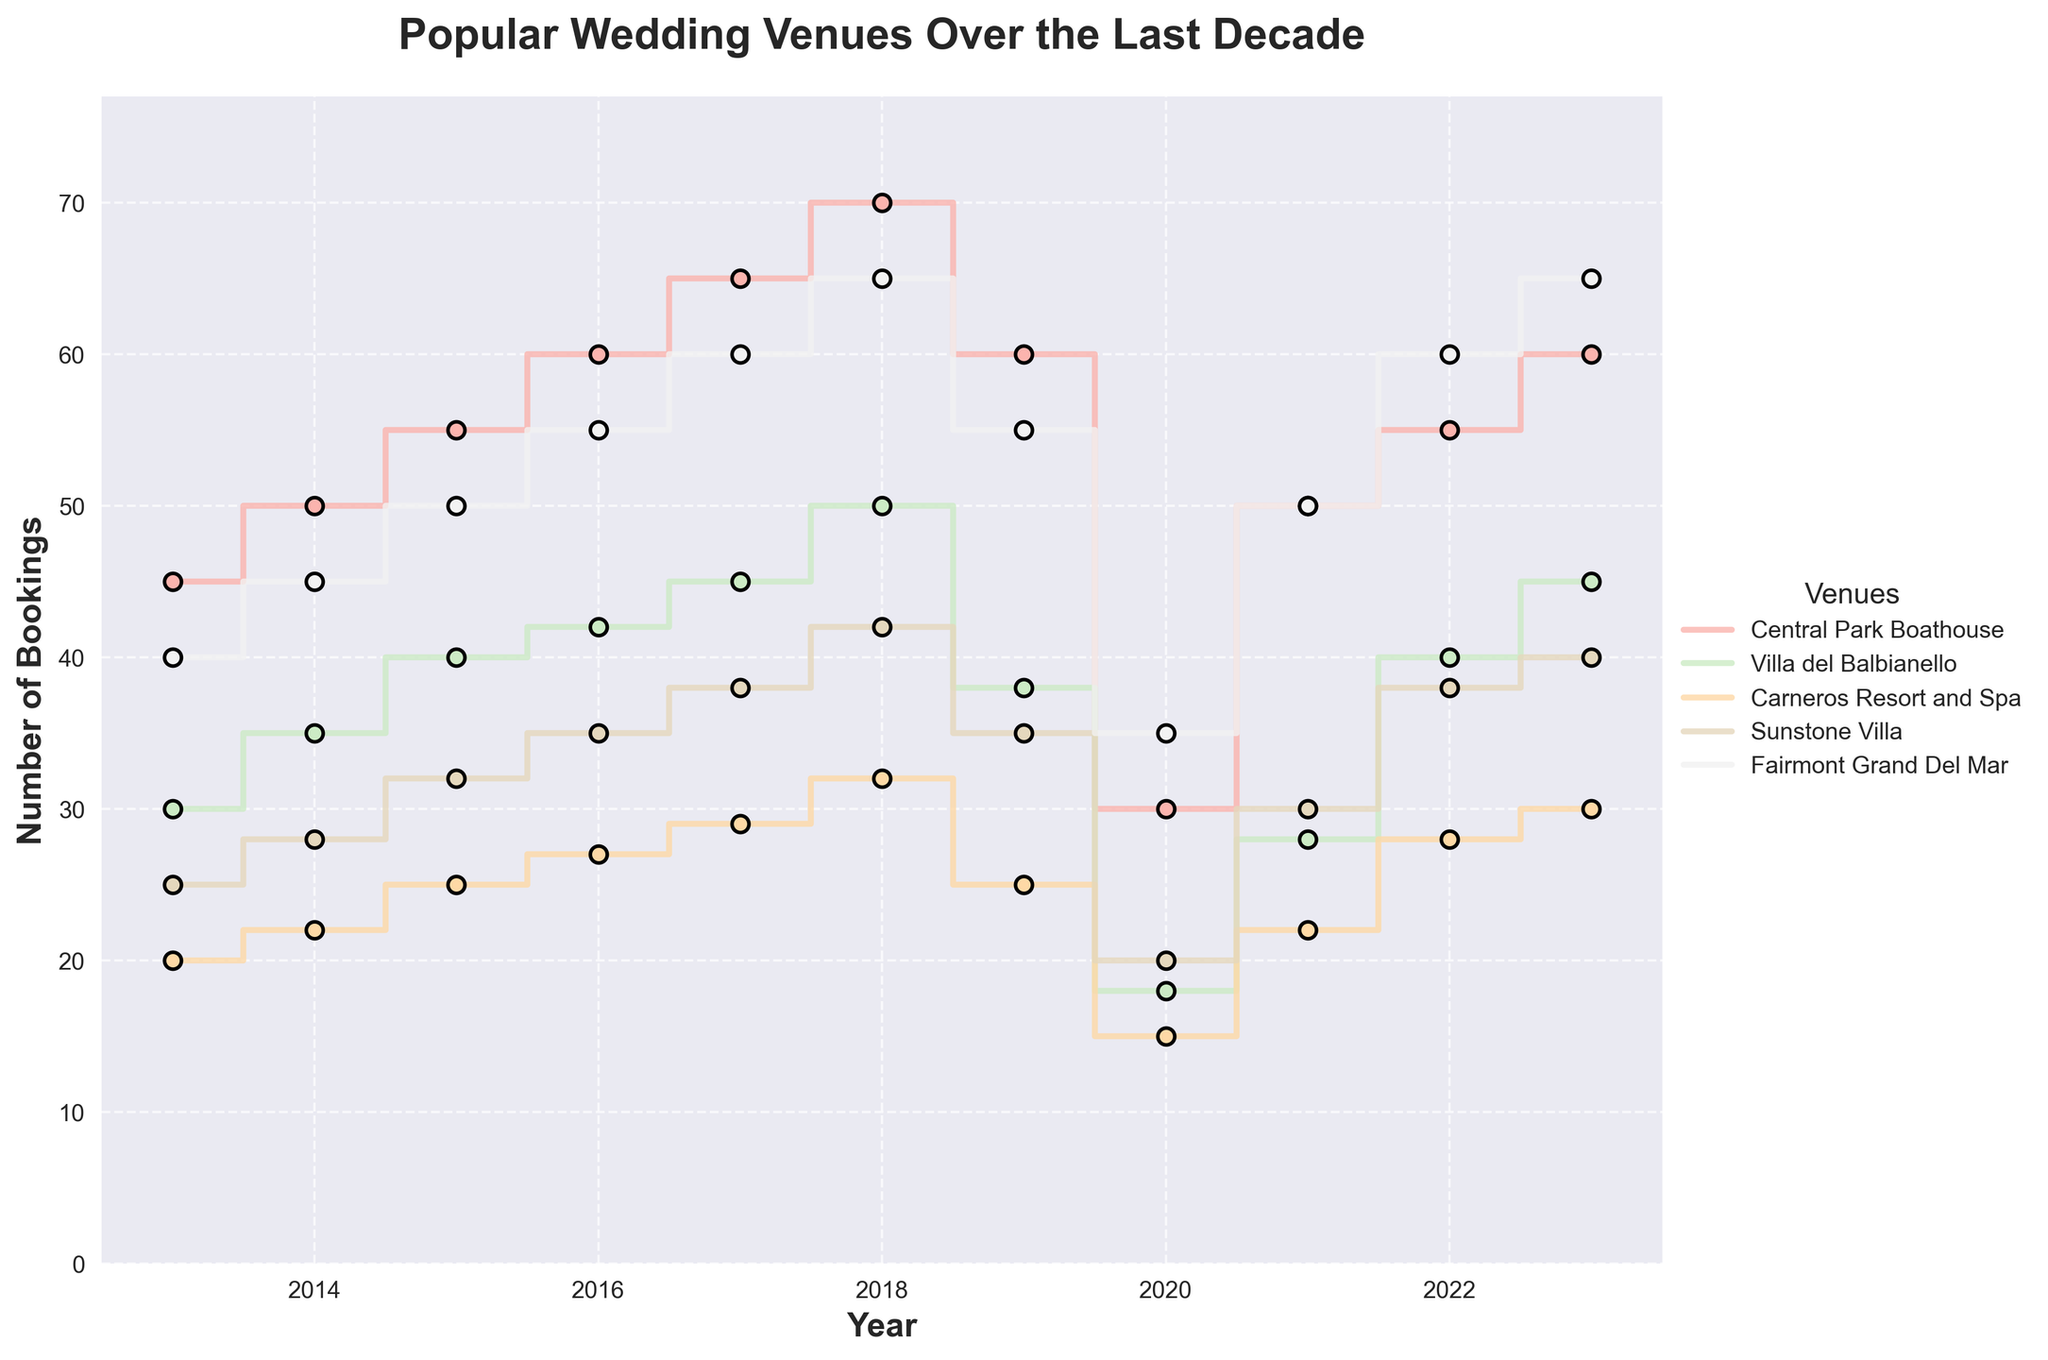What's the title of the figure? The title of the figure is written at the top, which provides the context of the data being visualized. The title in this figure reads: "Popular Wedding Venues Over the Last Decade."
Answer: Popular Wedding Venues Over the Last Decade Which venue had the highest number of bookings in 2023? To find this, look at the last data point (2023) for each venue's line. The highest number of bookings in 2023 is observed for "Fairmont Grand Del Mar" with 65 bookings.
Answer: Fairmont Grand Del Mar How did the bookings for Central Park Boathouse change from 2019 to 2020? Locate the points for Central Park Boathouse in 2019 and 2020, then calculate the difference. Bookings in 2019 were 60 and dropped to 30 in 2020.
Answer: Decreased by 30 What was the average number of bookings for Villa del Balbianello from 2013 to 2019? Add the number of bookings from 2013 to 2019 for Villa del Balbianello and divide by the number of years (7). (30+35+40+42+45+50+38)/7 = 280/7 = 40
Answer: 40 Which venue experienced the largest drop in bookings from 2019 to 2020? Compare the drops in bookings for each venue from 2019 to 2020. The largest drop is for Central Park Boathouse, from 60 to 30, a decrease of 30 bookings.
Answer: Central Park Boathouse Did any venue have a constant increase in bookings from 2013 to 2018 without any drop? Look at each venue's trend from 2013 to 2018. Central Park Boathouse shows a consistent increase in bookings each year from 45 to 70.
Answer: Yes, Central Park Boathouse Between which consecutive years did Sunstone Villa see the highest increase in bookings? Calculate the differences in bookings for Sunstone Villa between each consecutive year. The highest increase occurs between 2021 and 2022, from 30 to 38, an increase of 8.
Answer: Between 2021 and 2022 Which venue had the highest average bookings over the decade? Find the average bookings for each venue over the decade and compare. Fairmont Grand Del Mar has the highest average with (40+45+50+55+60+65+55+35+50+60+65)/11 which is around 53.2.
Answer: Fairmont Grand Del Mar How did the bookings trend for Carneros Resort and Spa from 2013 to 2023? Observe the step line for Carneros Resort and Spa over the years. It shows a generally upward trend, with a slight dip in 2019 and 2020, but overall the bookings increased from 20 to 30.
Answer: Generally upward Which year had the lowest total bookings across all venues? Add up the bookings for each venue for each year and compare totals. The year 2020 had the lowest total bookings due to significant drops across all venues.
Answer: 2020 